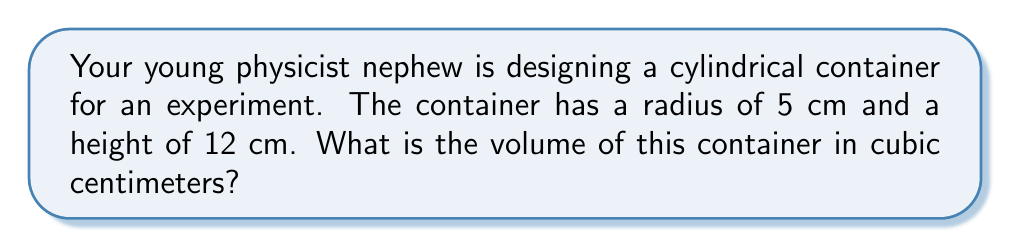Give your solution to this math problem. Let's approach this step-by-step:

1) The volume of a cylinder is given by the formula:
   $$V = \pi r^2 h$$
   where $V$ is volume, $r$ is radius, and $h$ is height.

2) We're given:
   Radius $(r) = 5$ cm
   Height $(h) = 12$ cm

3) Let's substitute these values into our formula:
   $$V = \pi (5\text{ cm})^2 (12\text{ cm})$$

4) First, calculate the square of the radius:
   $$V = \pi (25\text{ cm}^2) (12\text{ cm})$$

5) Multiply the terms inside the parentheses:
   $$V = \pi (300\text{ cm}^3)$$

6) Now, let's use $\pi \approx 3.14159$:
   $$V \approx 3.14159 (300\text{ cm}^3)$$

7) Calculate the final result:
   $$V \approx 942.48\text{ cm}^3$$

8) Rounding to two decimal places:
   $$V \approx 942.48\text{ cm}^3$$
Answer: $942.48\text{ cm}^3$ 